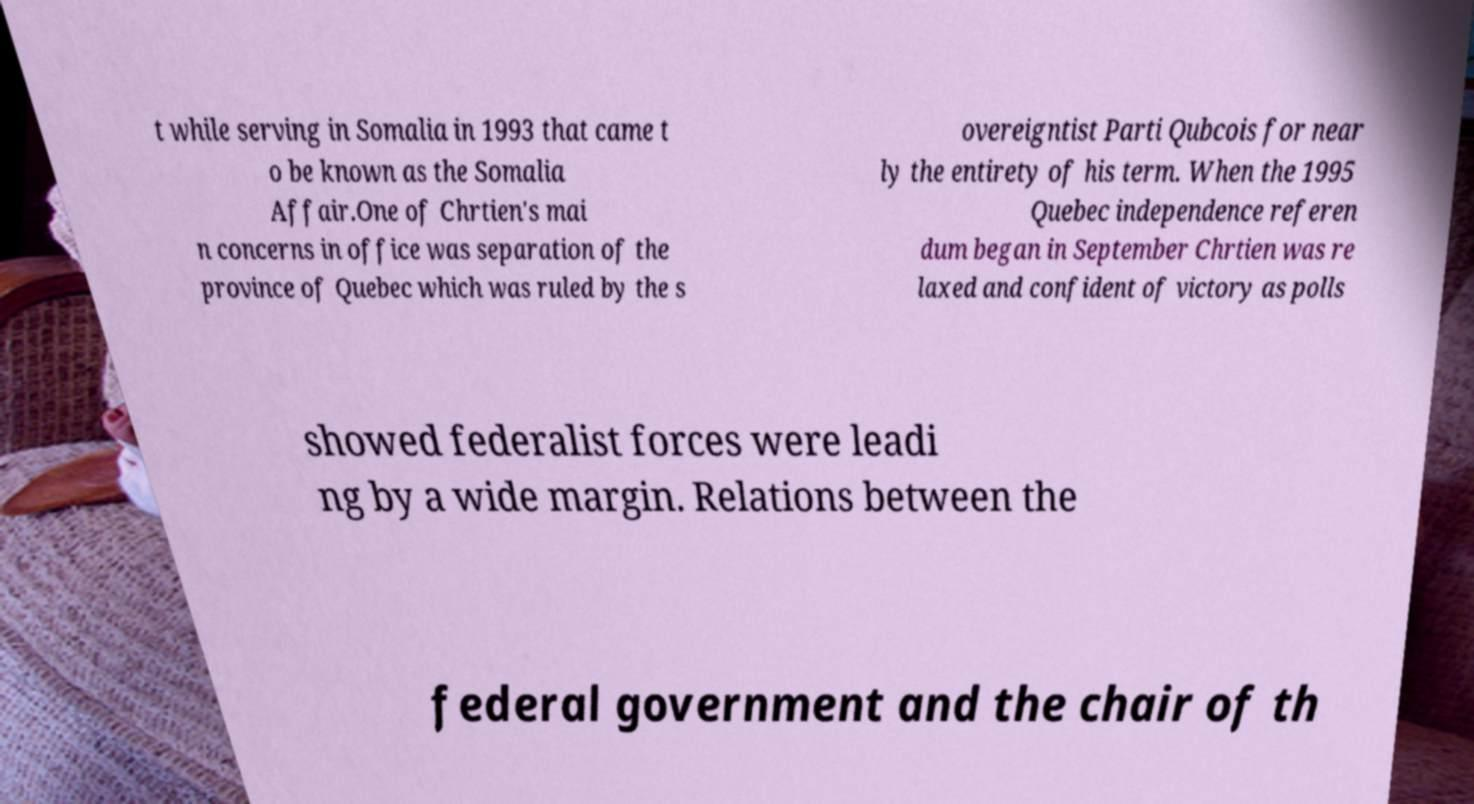Could you assist in decoding the text presented in this image and type it out clearly? t while serving in Somalia in 1993 that came t o be known as the Somalia Affair.One of Chrtien's mai n concerns in office was separation of the province of Quebec which was ruled by the s overeigntist Parti Qubcois for near ly the entirety of his term. When the 1995 Quebec independence referen dum began in September Chrtien was re laxed and confident of victory as polls showed federalist forces were leadi ng by a wide margin. Relations between the federal government and the chair of th 